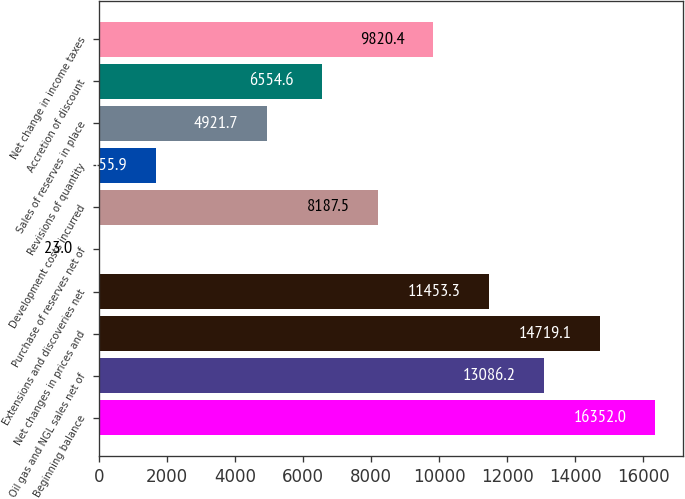<chart> <loc_0><loc_0><loc_500><loc_500><bar_chart><fcel>Beginning balance<fcel>Oil gas and NGL sales net of<fcel>Net changes in prices and<fcel>Extensions and discoveries net<fcel>Purchase of reserves net of<fcel>Development costs incurred<fcel>Revisions of quantity<fcel>Sales of reserves in place<fcel>Accretion of discount<fcel>Net change in income taxes<nl><fcel>16352<fcel>13086.2<fcel>14719.1<fcel>11453.3<fcel>23<fcel>8187.5<fcel>1655.9<fcel>4921.7<fcel>6554.6<fcel>9820.4<nl></chart> 